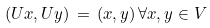<formula> <loc_0><loc_0><loc_500><loc_500>( U x , U y ) \, = \, ( x , y ) \, \forall x , y \in V</formula> 